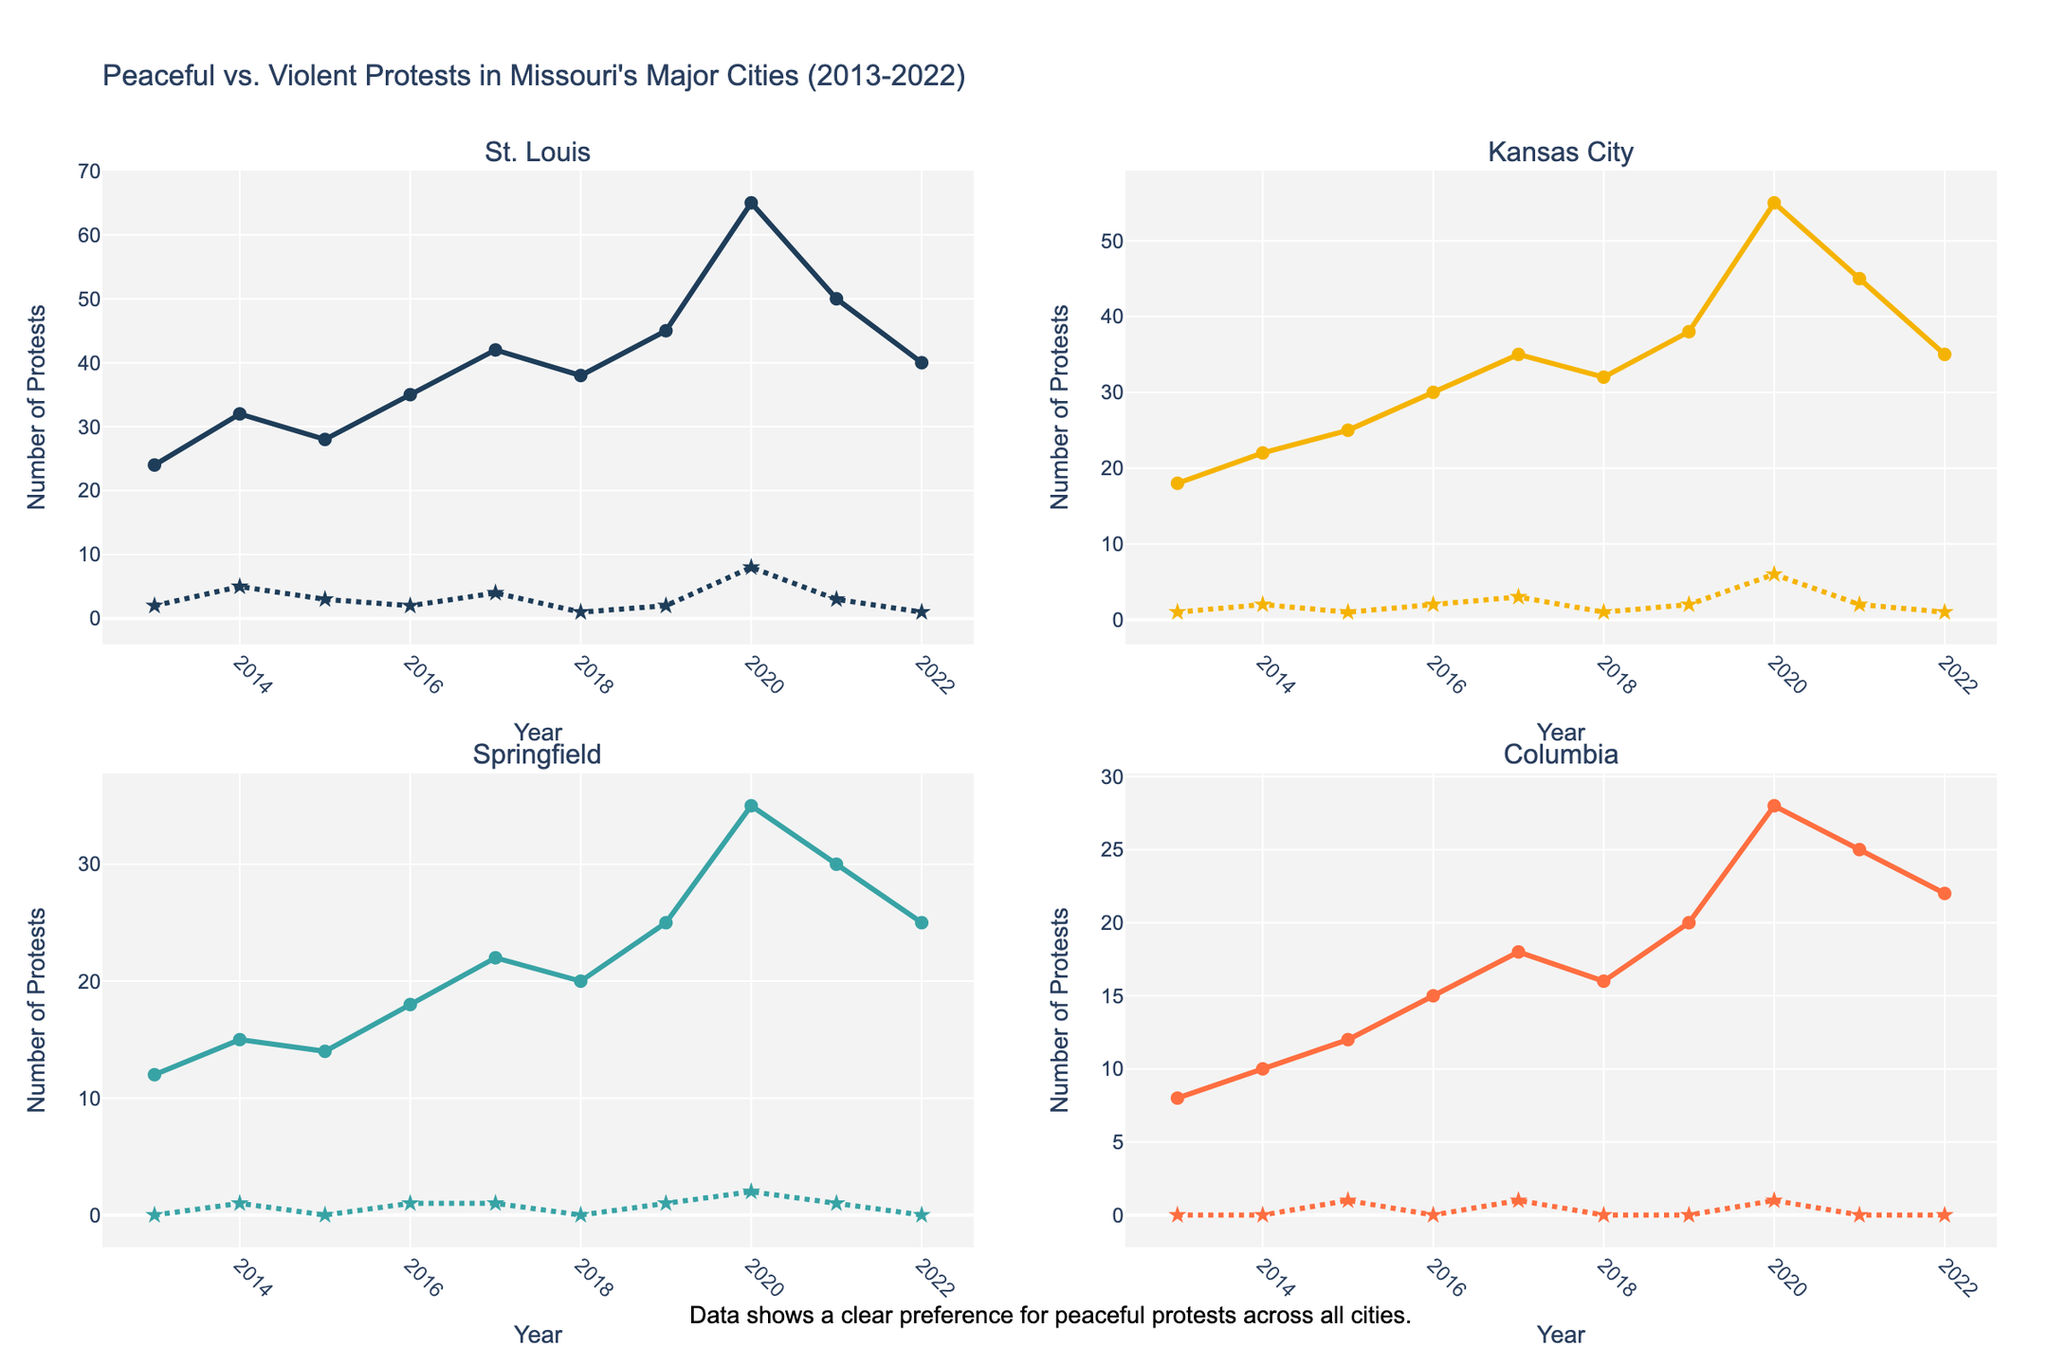How many violent protests were there in Kansas City in 2020? Look at the line representing violent protests for Kansas City and find the data point for the year 2020.
Answer: 6 Which city had the highest number of peaceful protests in 2017? Compare the data points for peaceful protests in all cities for the year 2017. The highest number is for St. Louis.
Answer: St. Louis What was the difference in the number of peaceful protests between St. Louis and Columbia in 2022? Subtract the number of peaceful protests in Columbia (22) from the number in St. Louis (40) for the year 2022.
Answer: 18 Did the number of violent protests increase or decrease in Springfield from 2014 to 2020? Compare the data points for violent protests in Springfield for the years 2014 (1) and 2020 (2).
Answer: Increase Which city had zero violent protests for the most years, and how many years? Count the years each city had zero violent protests. Springfield and Columbia both had zero violent protests for the most years—Springfield for 5 years and Columbia for 6 years.
Answer: Columbia, 6 years What is the average number of peaceful protests in Kansas City over the decade? Sum the data points for peaceful protests in Kansas City from 2013 to 2022 and divide by the number of years. (18+22+25+30+35+32+38+55+45+35)/10 = 33.5
Answer: 33.5 Which city's violent protests decreased from 2021 to 2022? Compare the data points for violent protests in each city for the years 2021 and 2022 to see where the numbers decreased. Violent protests decreased in St. Louis, Kansas City, and Columbia.
Answer: St. Louis, Kansas City, Columbia Which city had the least number of peaceful protests in 2020 and what was the count? Compare the data points for peaceful protests in all cities for the year 2020 and find the smallest number. The least number is in Columbia.
Answer: Columbia, 28 Between 2015 and 2020, how many times did the number of peaceful protests in St. Louis exceed 40? Check the data points for peaceful protests in St. Louis for each year from 2015 to 2020 to see how many times it exceeded 40. It exceeded 40 in 2017, 2019, and 2020.
Answer: 3 times Which year had the highest number of violent protests in St. Louis, and what was that number? Identify the highest data point for violent protests in St. Louis and note the corresponding year.
Answer: 2020, 8 